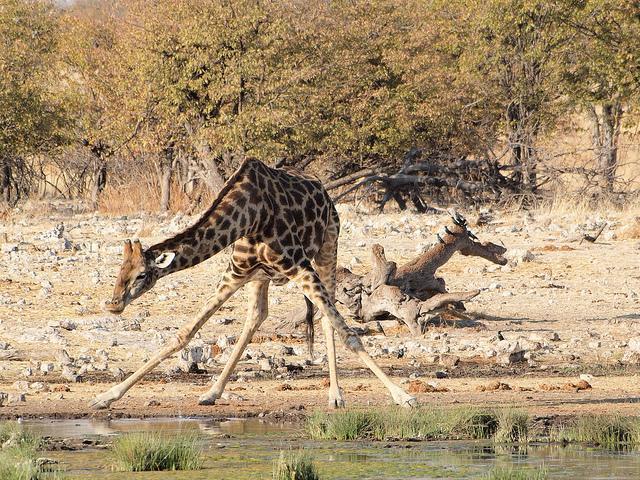How many chairs are in the room?
Give a very brief answer. 0. 